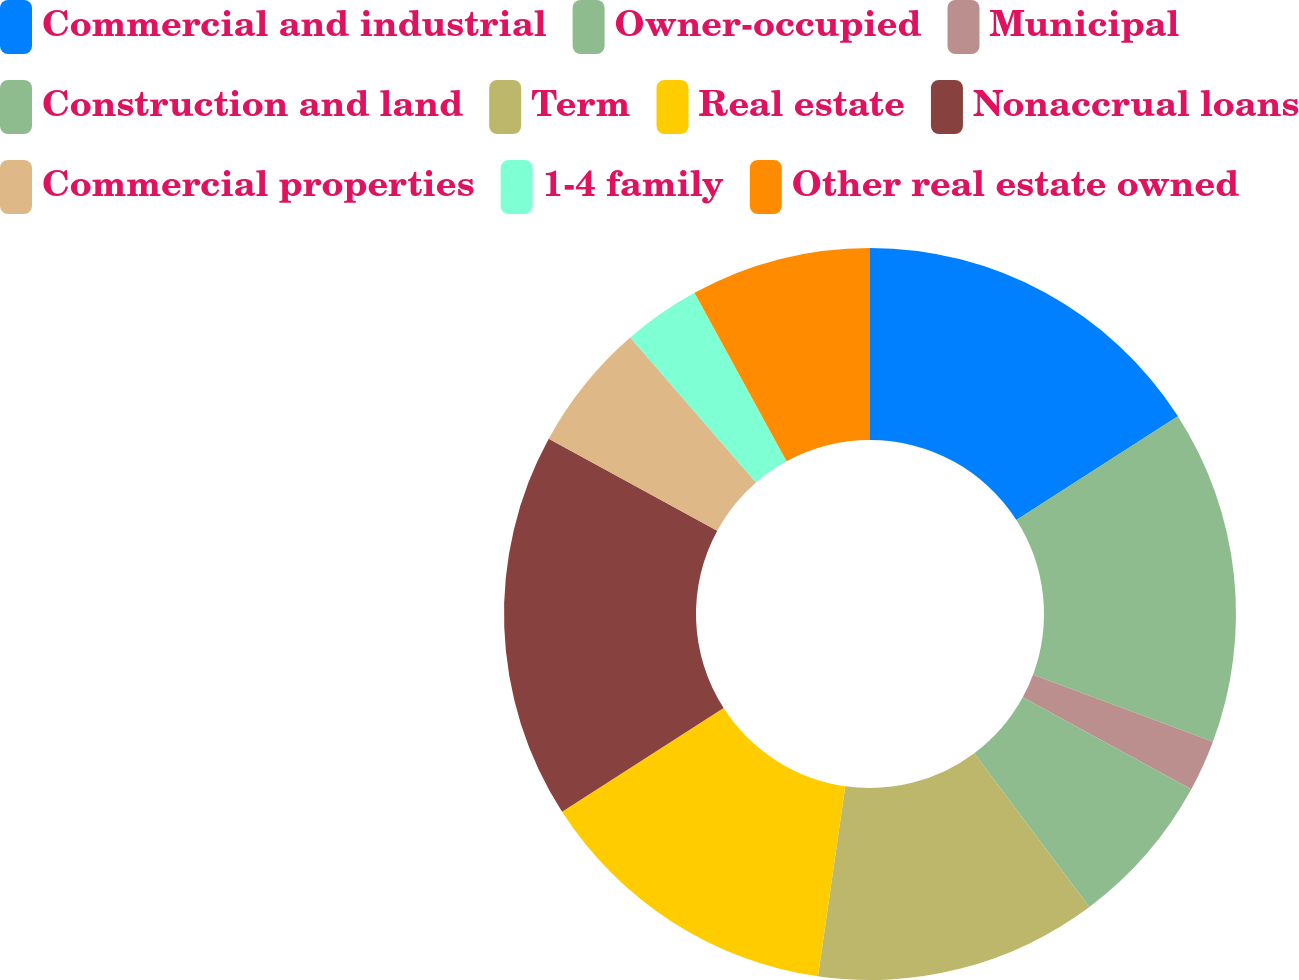Convert chart to OTSL. <chart><loc_0><loc_0><loc_500><loc_500><pie_chart><fcel>Commercial and industrial<fcel>Owner-occupied<fcel>Municipal<fcel>Construction and land<fcel>Term<fcel>Real estate<fcel>Nonaccrual loans<fcel>Commercial properties<fcel>1-4 family<fcel>Other real estate owned<nl><fcel>15.91%<fcel>14.77%<fcel>2.27%<fcel>6.82%<fcel>12.5%<fcel>13.64%<fcel>17.04%<fcel>5.68%<fcel>3.41%<fcel>7.96%<nl></chart> 